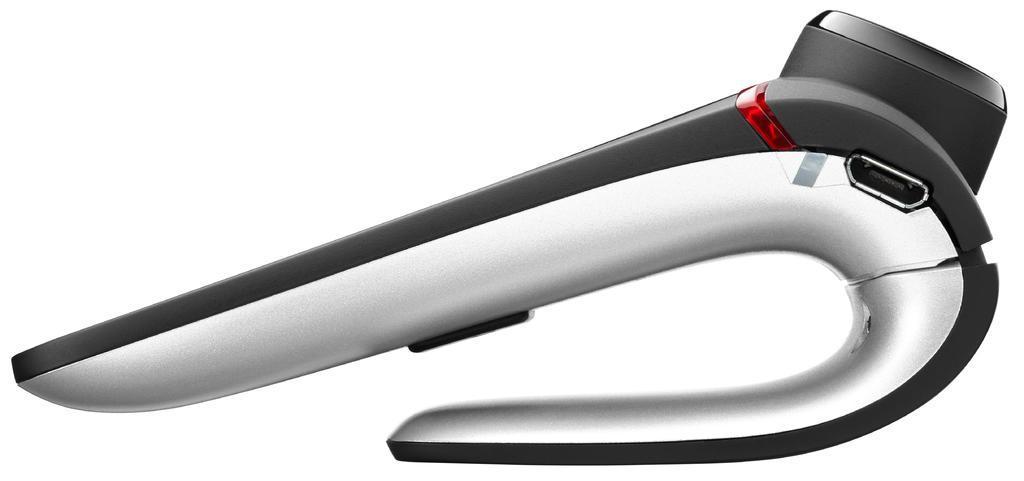Can you describe this image briefly? In the center of the image there is a bluetooth earphone. 